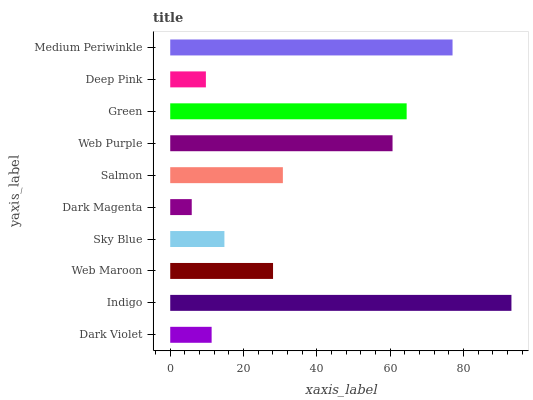Is Dark Magenta the minimum?
Answer yes or no. Yes. Is Indigo the maximum?
Answer yes or no. Yes. Is Web Maroon the minimum?
Answer yes or no. No. Is Web Maroon the maximum?
Answer yes or no. No. Is Indigo greater than Web Maroon?
Answer yes or no. Yes. Is Web Maroon less than Indigo?
Answer yes or no. Yes. Is Web Maroon greater than Indigo?
Answer yes or no. No. Is Indigo less than Web Maroon?
Answer yes or no. No. Is Salmon the high median?
Answer yes or no. Yes. Is Web Maroon the low median?
Answer yes or no. Yes. Is Dark Magenta the high median?
Answer yes or no. No. Is Salmon the low median?
Answer yes or no. No. 